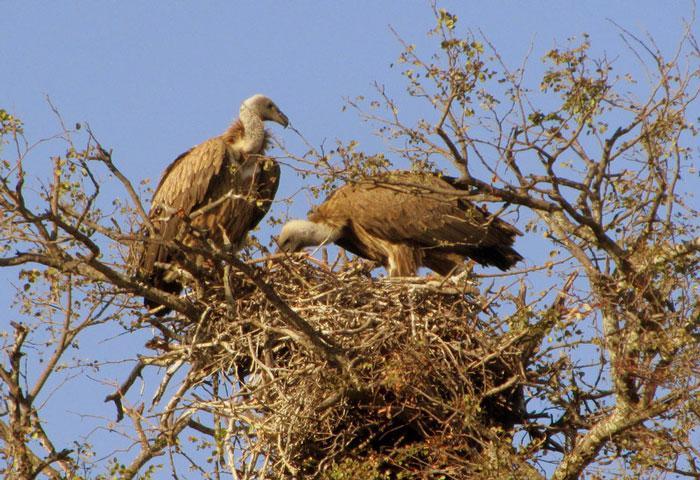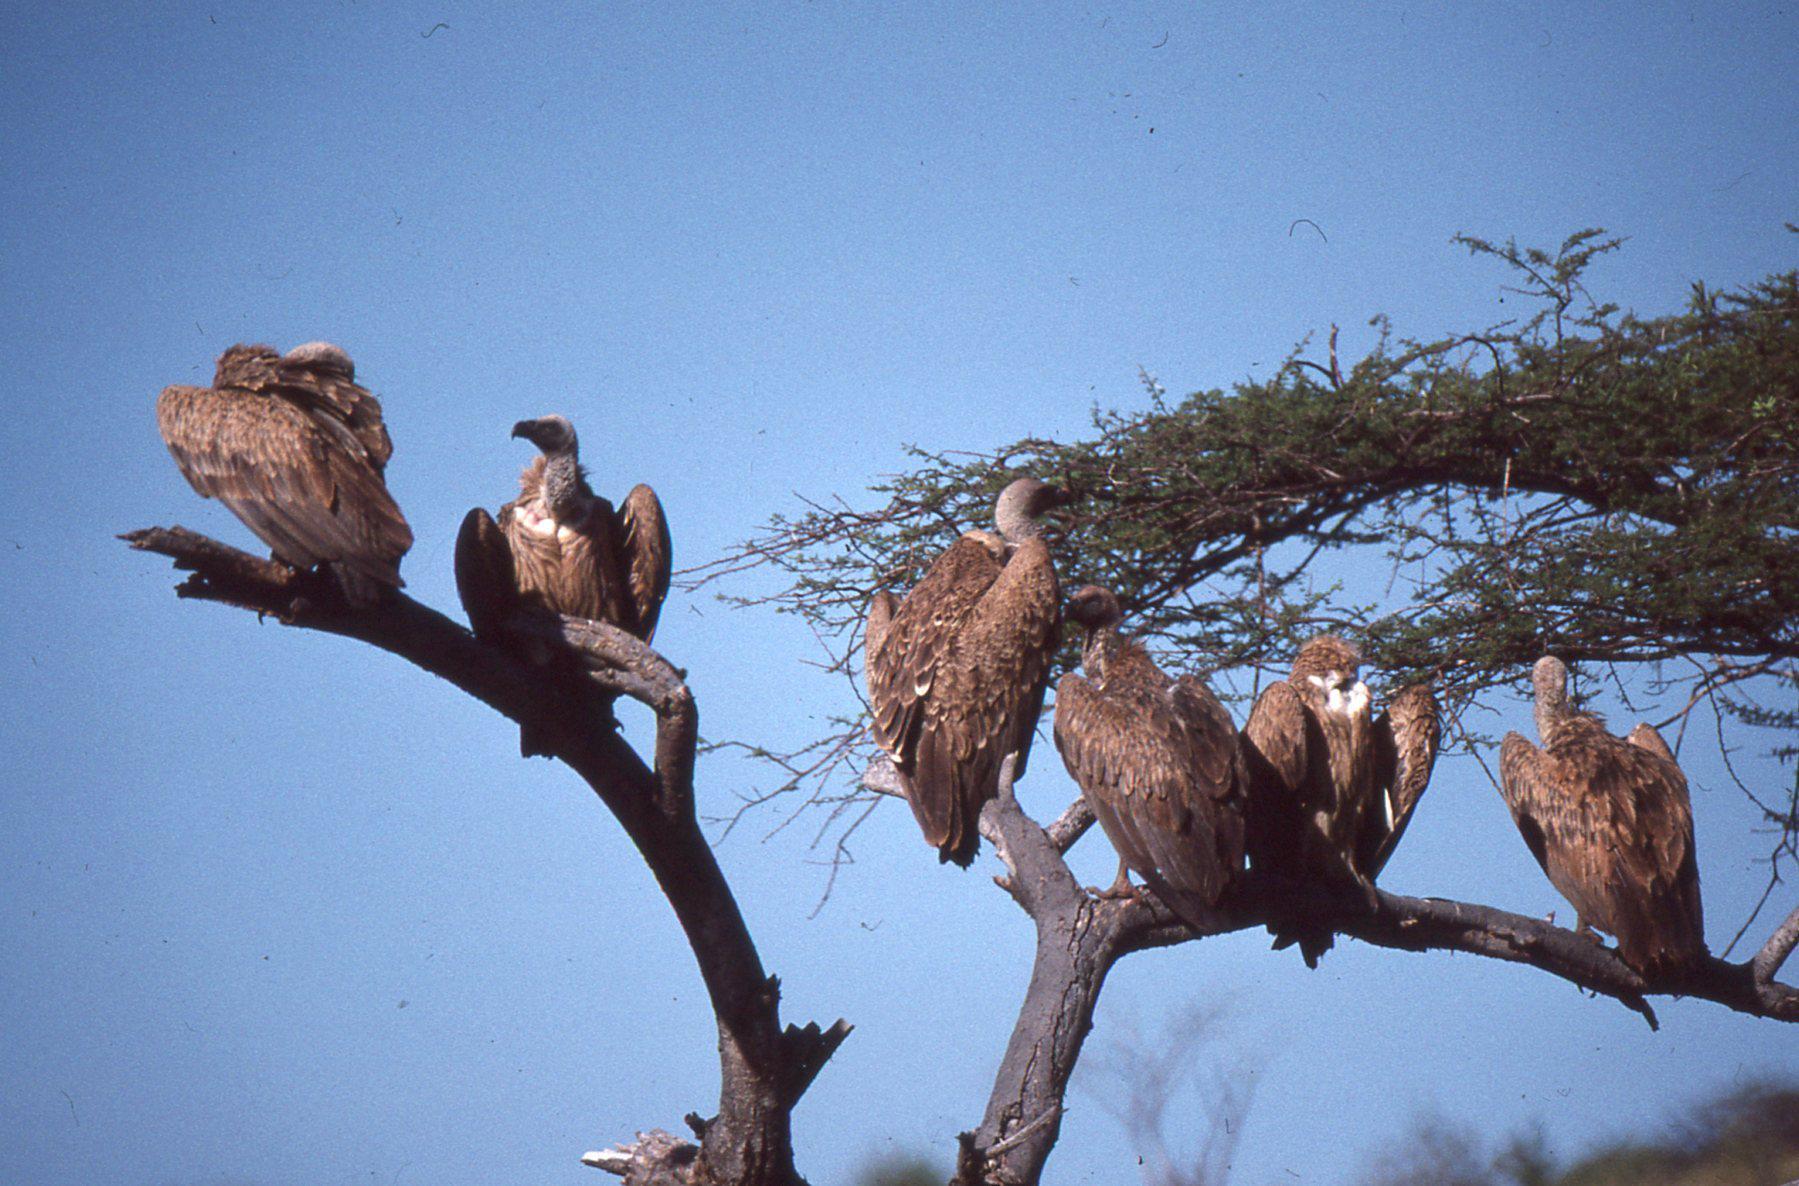The first image is the image on the left, the second image is the image on the right. For the images shown, is this caption "One image shows exactly two vultures in a nest of sticks and leaves, and the other image shows several vultures perched on leafless branches." true? Answer yes or no. Yes. The first image is the image on the left, the second image is the image on the right. Considering the images on both sides, is "Birds are sitting on tree branches in both images." valid? Answer yes or no. Yes. 